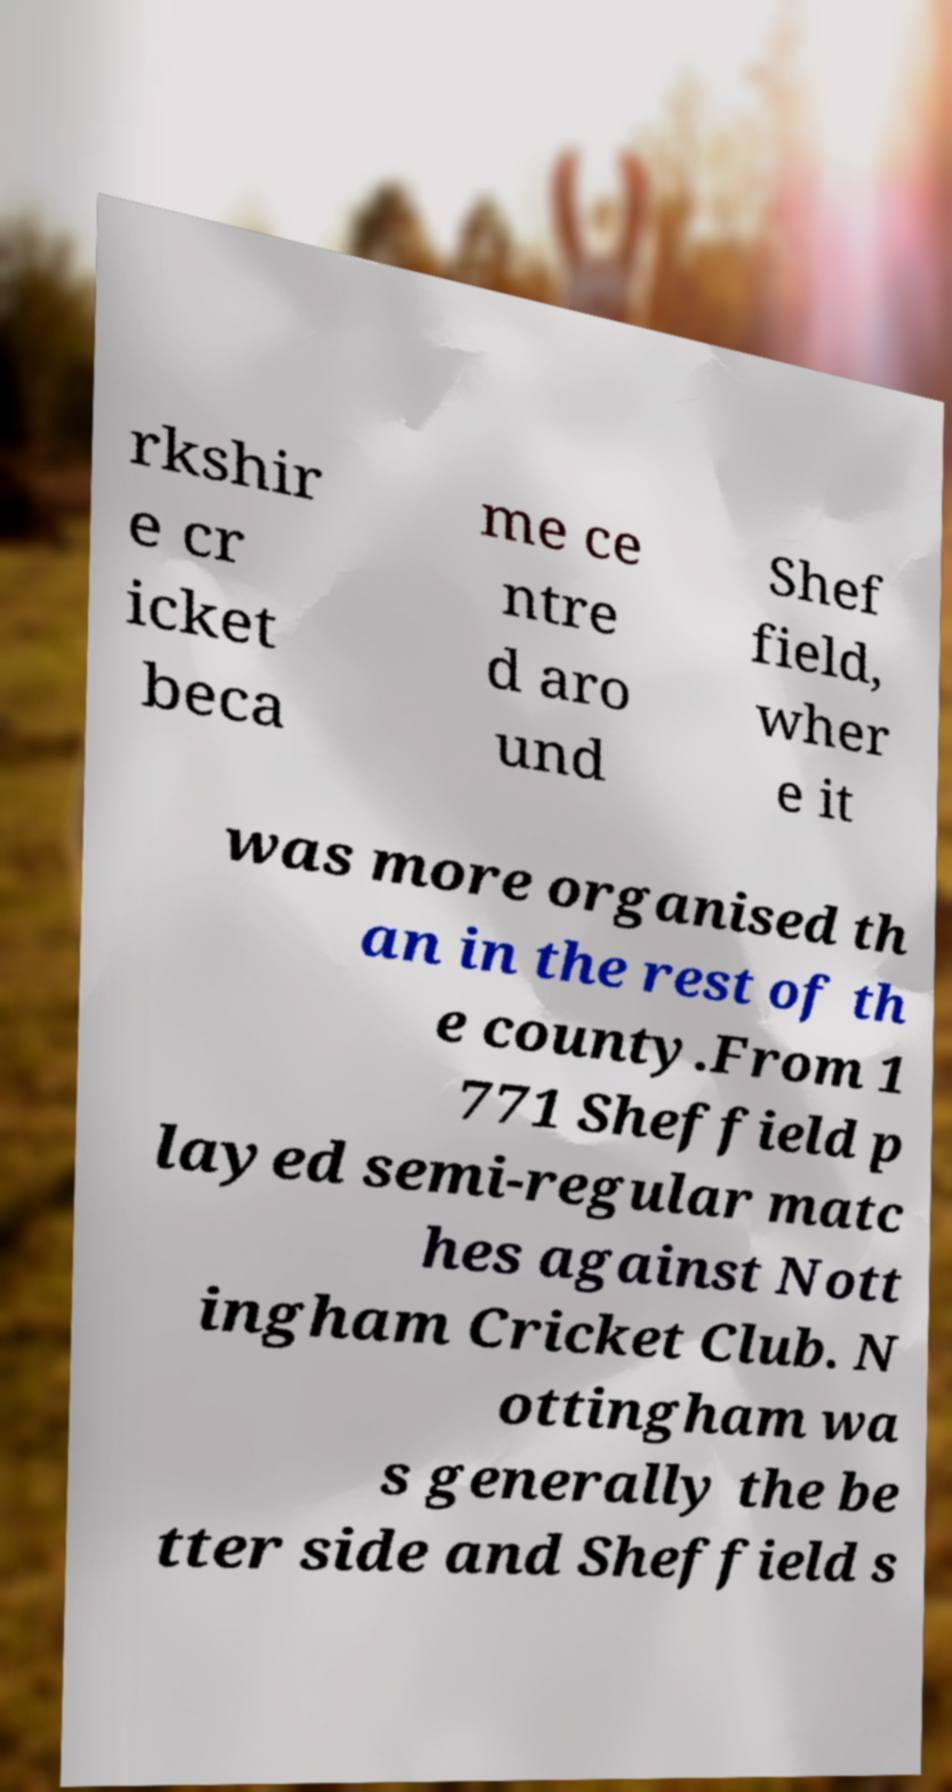What messages or text are displayed in this image? I need them in a readable, typed format. rkshir e cr icket beca me ce ntre d aro und Shef field, wher e it was more organised th an in the rest of th e county.From 1 771 Sheffield p layed semi-regular matc hes against Nott ingham Cricket Club. N ottingham wa s generally the be tter side and Sheffield s 